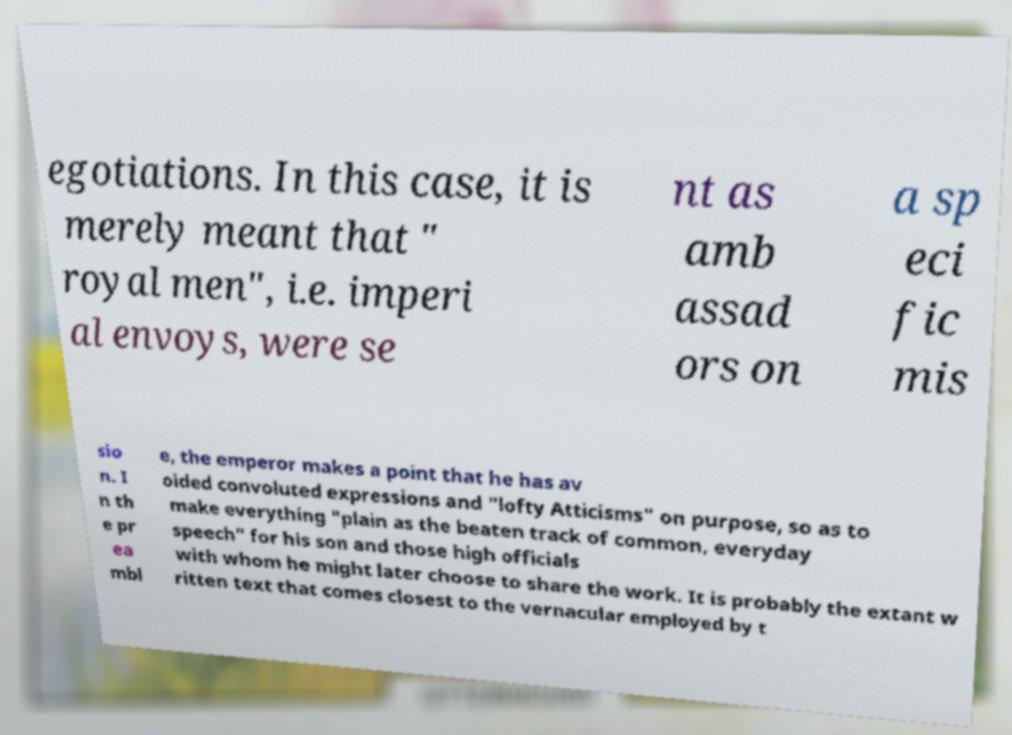Can you accurately transcribe the text from the provided image for me? egotiations. In this case, it is merely meant that " royal men", i.e. imperi al envoys, were se nt as amb assad ors on a sp eci fic mis sio n. I n th e pr ea mbl e, the emperor makes a point that he has av oided convoluted expressions and "lofty Atticisms" on purpose, so as to make everything "plain as the beaten track of common, everyday speech" for his son and those high officials with whom he might later choose to share the work. It is probably the extant w ritten text that comes closest to the vernacular employed by t 